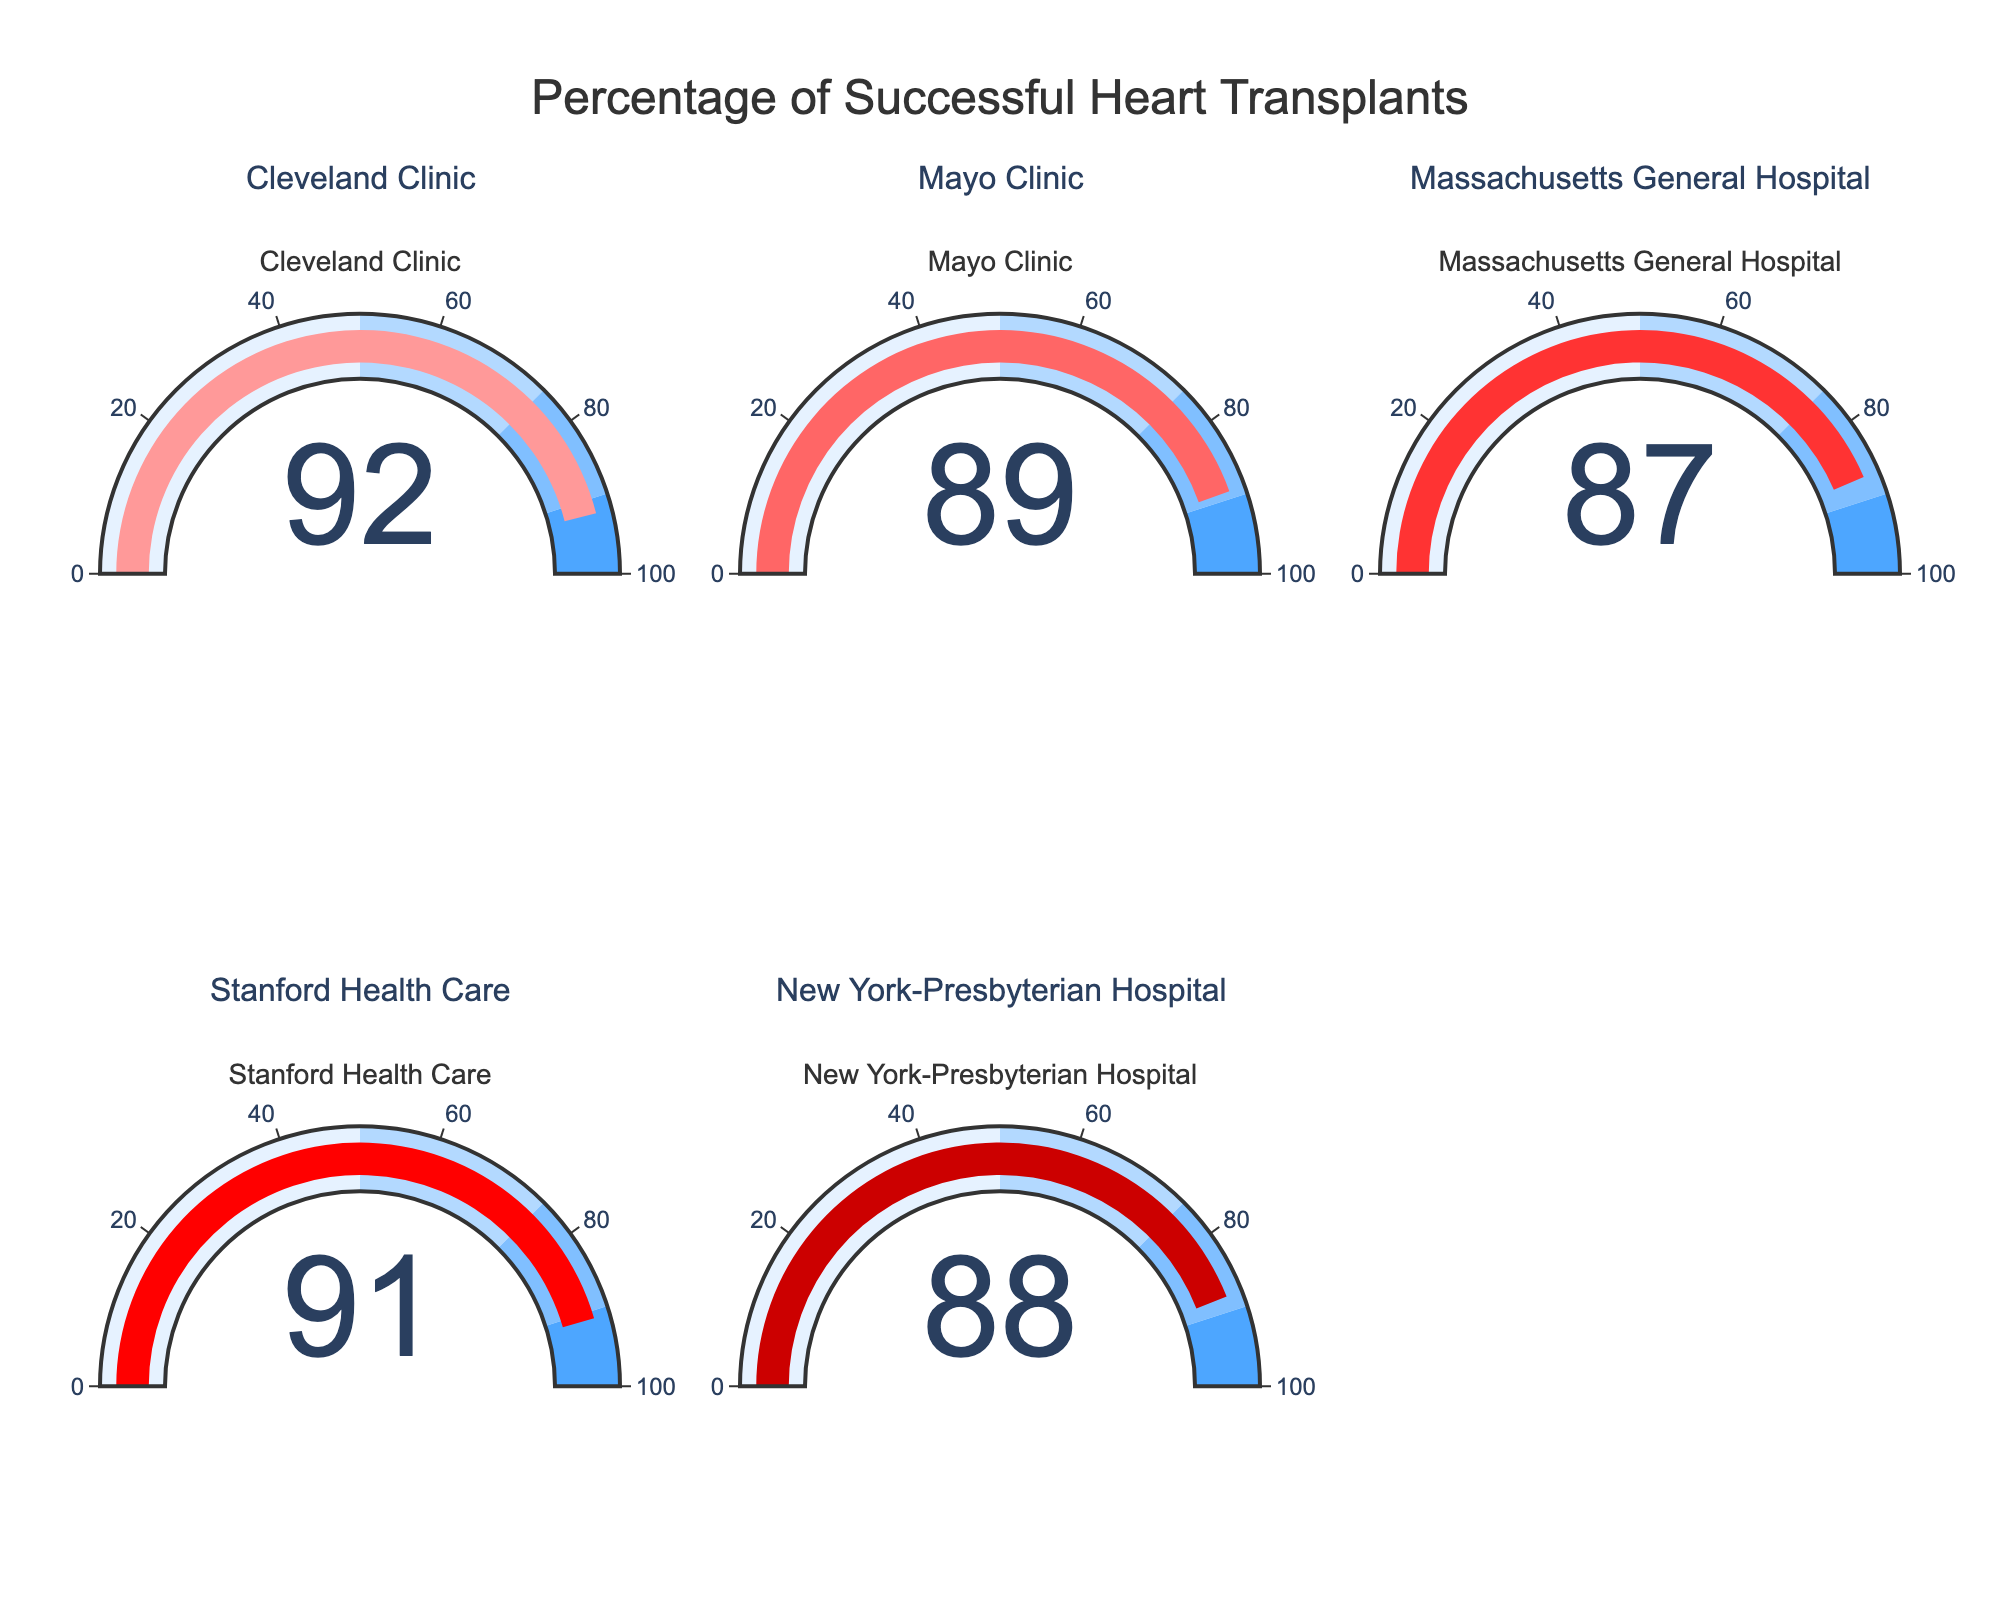what is the highest success rate shown in the chart? To find the highest success rate, look at the numbers displayed on the gauge charts. The highest number among Cleveland Clinic (92), Mayo Clinic (89), Massachusetts General Hospital (87), Stanford Health Care (91), and New York-Presbyterian Hospital (88) is 92.
Answer: 92 Which hospital has the lowest success rate? To determine the hospital with the lowest success rate, examine the success rates shown on the gauge charts. The numbers are Cleveland Clinic (92), Mayo Clinic (89), Massachusetts General Hospital (87), Stanford Health Care (91), New York-Presbyterian Hospital (88). The lowest number is 87, pertaining to Massachusetts General Hospital.
Answer: Massachusetts General Hospital What is the average success rate of all hospitals? To find the average success rate, sum all success rates and divide by the number of hospitals. Success rates: 92, 89, 87, 91, and 88. Sum: 92 + 89 + 87 + 91 + 88 = 447. Average: 447 / 5 = 89.4
Answer: 89.4 How many hospitals have a success rate above 90? To find the number of hospitals with success rates above 90, count each instance where the gauge chart shows a number greater than 90. Cleveland Clinic (92), Stanford Health Care (91) are above 90. Therefore, there are 2 hospitals.
Answer: 2 Which hospital is represented by the color #FF9999? To identify the hospital represented by the color #FF9999, check the first color assigned from the custom color scale. It corresponds to the success rate of Cleveland Clinic, which is the first data point.
Answer: Cleveland Clinic What is the difference in success rates between the hospital with the highest and lowest rates? To determine the difference, subtract the lowest success rate from the highest success rate. The highest is 92 (Cleveland Clinic), and the lowest is 87 (Massachusetts General Hospital). Difference: 92 - 87 = 5
Answer: 5 What is the combined success rate of New York-Presbyterian Hospital and Mayo Clinic? To find the combined success rate, sum the success rates of New York-Presbyterian Hospital and Mayo Clinic. Success rates are 88 and 89 respectively. Combined: 88 + 89 = 177
Answer: 177 Between Stanford Health Care and Cleveland Clinic, which has a lower success rate and by how much? Compare the success rates of Stanford Health Care and Cleveland Clinic. Stanford Health Care has a rate of 91, and Cleveland Clinic has a rate of 92. Difference: 92 - 91 = 1. Therefore, Stanford Health Care has a lower rate by 1.
Answer: Stanford Health Care, by 1 Which two hospitals have the closest success rates, and what is the difference between them? To find the two hospitals with the closest success rates, examine the differences. Cleveland Clinic (92) and Stanford Health Care (91) differ by 1; Mayo Clinic (89) and New York-Presbyterian Hospital (88) differ by 1; Massachusetts General Hospital (87) and New York-Presbyterian Hospital (88) differ by 1. Closest pairs: 92-91, 89-88, and 88-87, difference is 1.
Answer: Multiple pairs, difference 1 